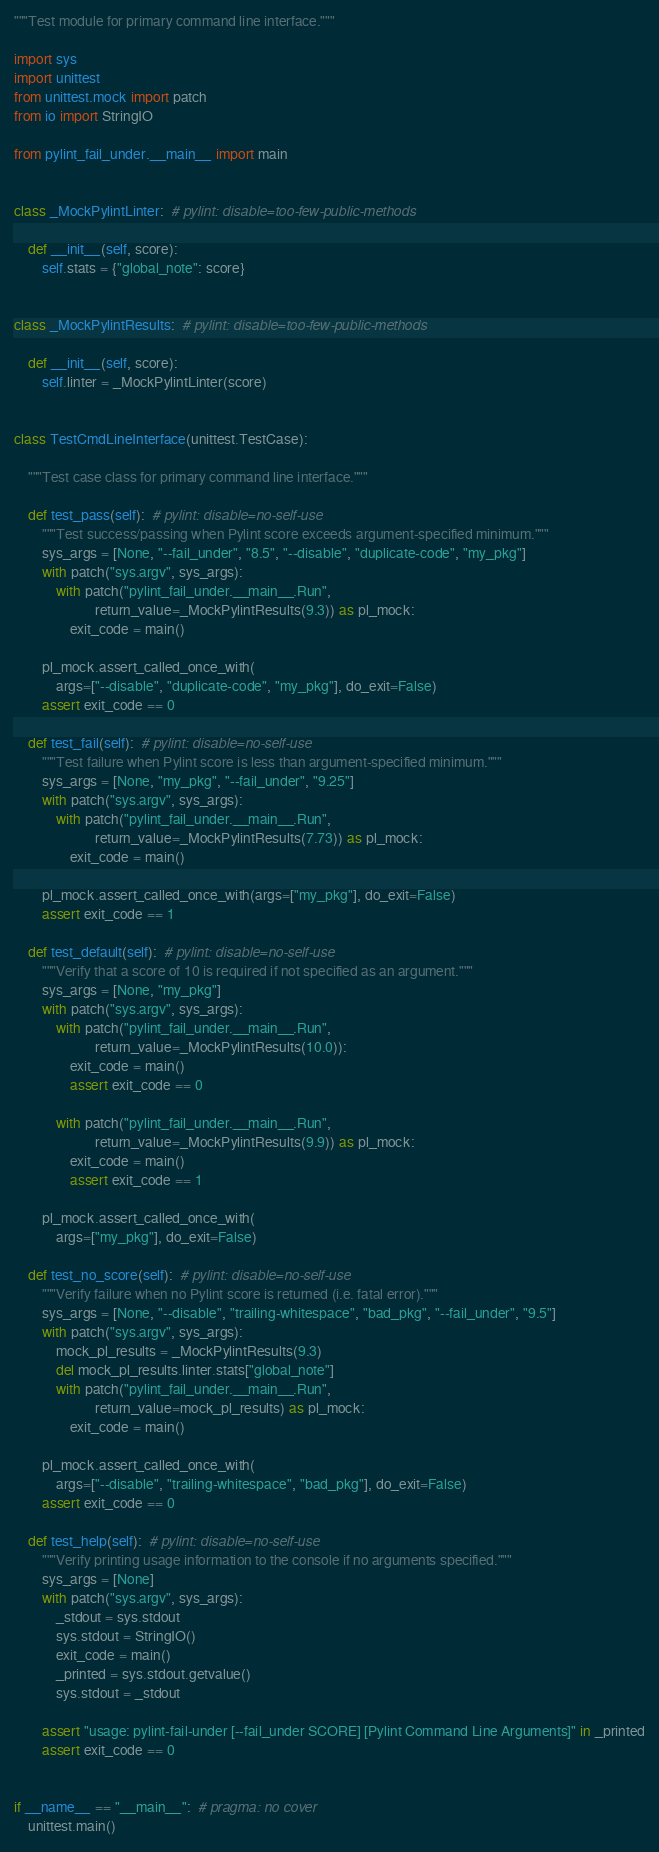Convert code to text. <code><loc_0><loc_0><loc_500><loc_500><_Python_>"""Test module for primary command line interface."""

import sys
import unittest
from unittest.mock import patch
from io import StringIO

from pylint_fail_under.__main__ import main


class _MockPylintLinter:  # pylint: disable=too-few-public-methods

    def __init__(self, score):
        self.stats = {"global_note": score}


class _MockPylintResults:  # pylint: disable=too-few-public-methods

    def __init__(self, score):
        self.linter = _MockPylintLinter(score)


class TestCmdLineInterface(unittest.TestCase):

    """Test case class for primary command line interface."""

    def test_pass(self):  # pylint: disable=no-self-use
        """Test success/passing when Pylint score exceeds argument-specified minimum."""
        sys_args = [None, "--fail_under", "8.5", "--disable", "duplicate-code", "my_pkg"]
        with patch("sys.argv", sys_args):
            with patch("pylint_fail_under.__main__.Run",
                       return_value=_MockPylintResults(9.3)) as pl_mock:
                exit_code = main()

        pl_mock.assert_called_once_with(
            args=["--disable", "duplicate-code", "my_pkg"], do_exit=False)
        assert exit_code == 0

    def test_fail(self):  # pylint: disable=no-self-use
        """Test failure when Pylint score is less than argument-specified minimum."""
        sys_args = [None, "my_pkg", "--fail_under", "9.25"]
        with patch("sys.argv", sys_args):
            with patch("pylint_fail_under.__main__.Run",
                       return_value=_MockPylintResults(7.73)) as pl_mock:
                exit_code = main()

        pl_mock.assert_called_once_with(args=["my_pkg"], do_exit=False)
        assert exit_code == 1

    def test_default(self):  # pylint: disable=no-self-use
        """Verify that a score of 10 is required if not specified as an argument."""
        sys_args = [None, "my_pkg"]
        with patch("sys.argv", sys_args):
            with patch("pylint_fail_under.__main__.Run",
                       return_value=_MockPylintResults(10.0)):
                exit_code = main()
                assert exit_code == 0

            with patch("pylint_fail_under.__main__.Run",
                       return_value=_MockPylintResults(9.9)) as pl_mock:
                exit_code = main()
                assert exit_code == 1

        pl_mock.assert_called_once_with(
            args=["my_pkg"], do_exit=False)

    def test_no_score(self):  # pylint: disable=no-self-use
        """Verify failure when no Pylint score is returned (i.e. fatal error)."""
        sys_args = [None, "--disable", "trailing-whitespace", "bad_pkg", "--fail_under", "9.5"]
        with patch("sys.argv", sys_args):
            mock_pl_results = _MockPylintResults(9.3)
            del mock_pl_results.linter.stats["global_note"]
            with patch("pylint_fail_under.__main__.Run",
                       return_value=mock_pl_results) as pl_mock:
                exit_code = main()

        pl_mock.assert_called_once_with(
            args=["--disable", "trailing-whitespace", "bad_pkg"], do_exit=False)
        assert exit_code == 0

    def test_help(self):  # pylint: disable=no-self-use
        """Verify printing usage information to the console if no arguments specified."""
        sys_args = [None]
        with patch("sys.argv", sys_args):
            _stdout = sys.stdout
            sys.stdout = StringIO()
            exit_code = main()
            _printed = sys.stdout.getvalue()
            sys.stdout = _stdout

        assert "usage: pylint-fail-under [--fail_under SCORE] [Pylint Command Line Arguments]" in _printed
        assert exit_code == 0


if __name__ == "__main__":  # pragma: no cover
    unittest.main()
</code> 